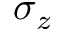<formula> <loc_0><loc_0><loc_500><loc_500>\sigma _ { z }</formula> 